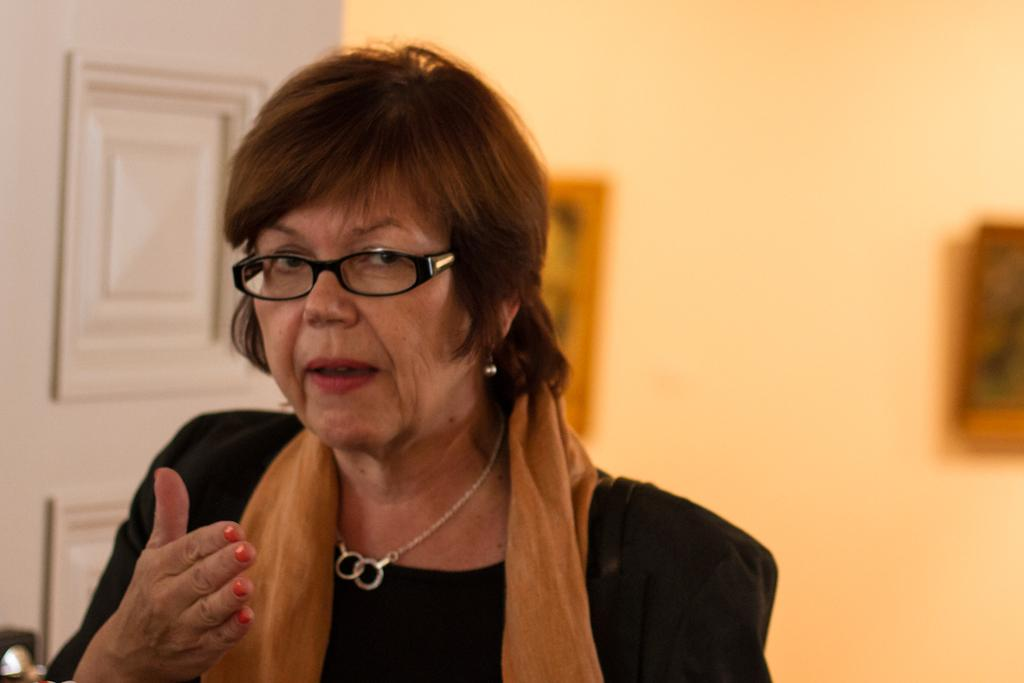Who is present in the image? There is a lady in the image. What is the lady wearing around her neck? The lady is wearing a scarf. What accessory is the lady wearing on her face? The lady is wearing glasses. What can be seen in the background of the image? There is a door in the background of the image. What decorative items are on the wall in the image? There are photo frames on the wall in the image. How many screws are visible on the lady's glasses in the image? There is no mention of screws on the lady's glasses in the image, so we cannot determine the number of screws. 